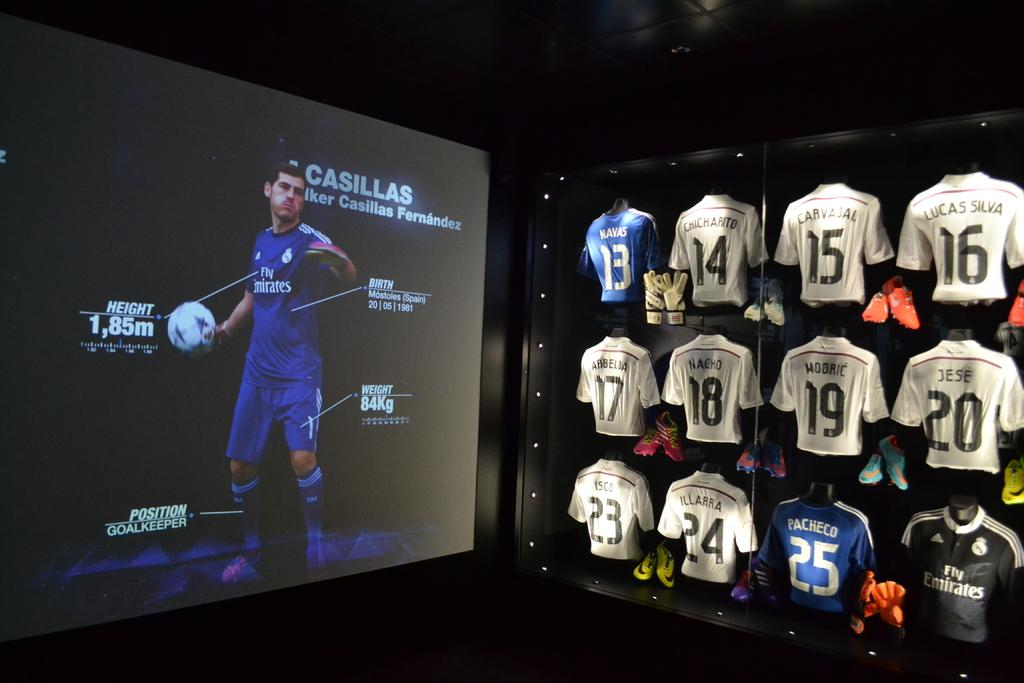Provide a one-sentence caption for the provided image. A display glass of jerseys in white and the only blue one has the number 13. 